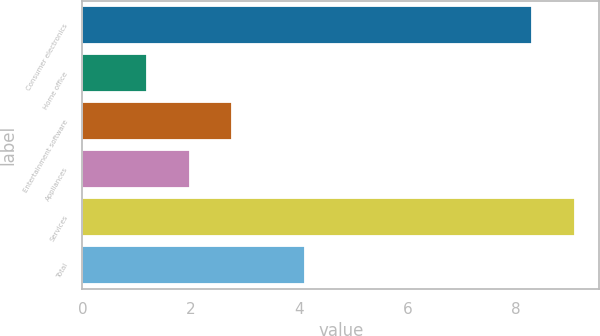Convert chart to OTSL. <chart><loc_0><loc_0><loc_500><loc_500><bar_chart><fcel>Consumer electronics<fcel>Home office<fcel>Entertainment software<fcel>Appliances<fcel>Services<fcel>Total<nl><fcel>8.3<fcel>1.2<fcel>2.76<fcel>1.98<fcel>9.08<fcel>4.1<nl></chart> 